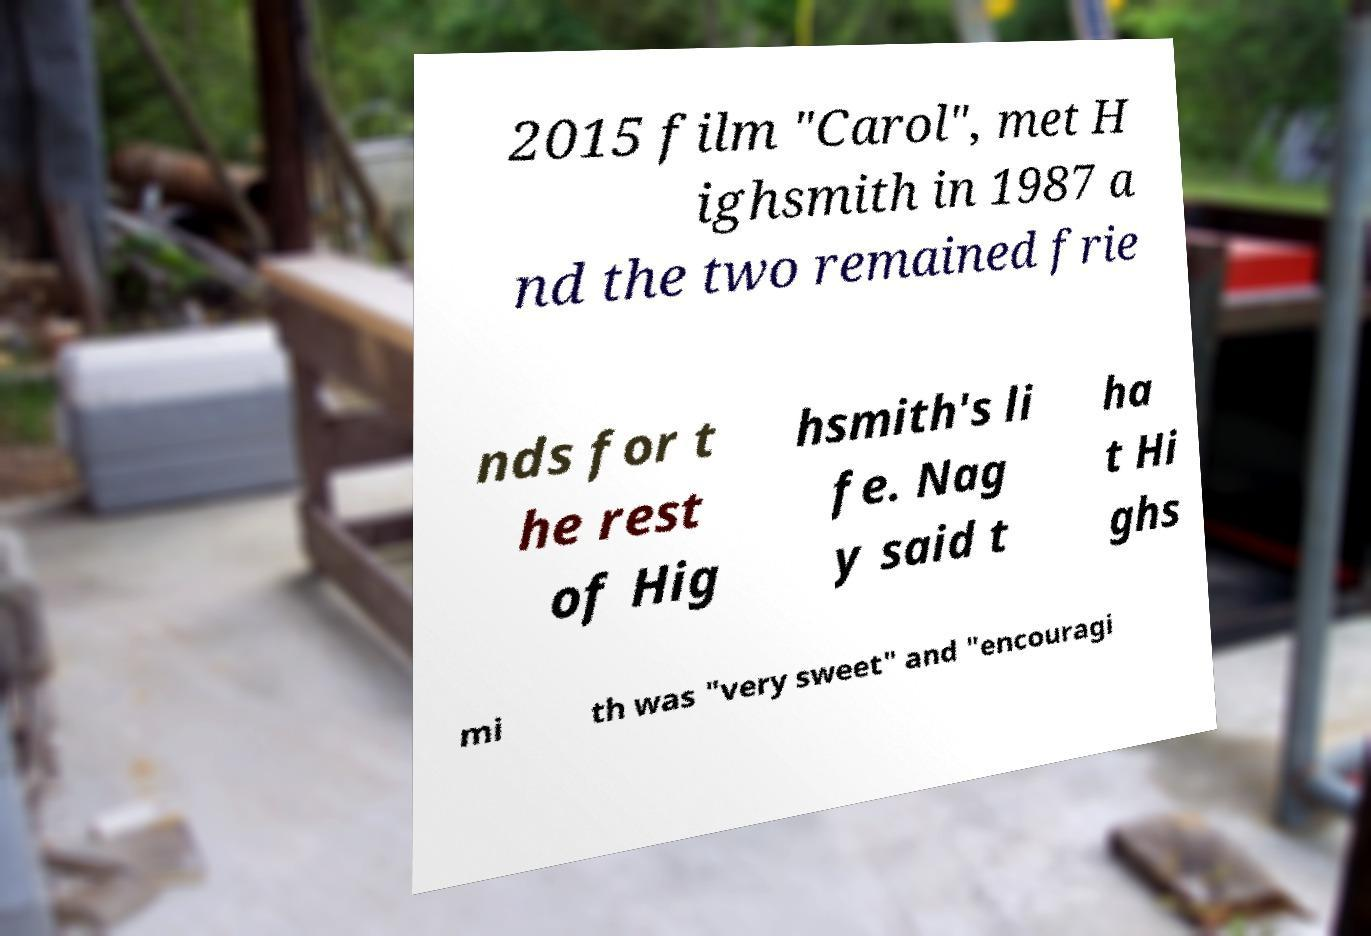For documentation purposes, I need the text within this image transcribed. Could you provide that? 2015 film "Carol", met H ighsmith in 1987 a nd the two remained frie nds for t he rest of Hig hsmith's li fe. Nag y said t ha t Hi ghs mi th was "very sweet" and "encouragi 